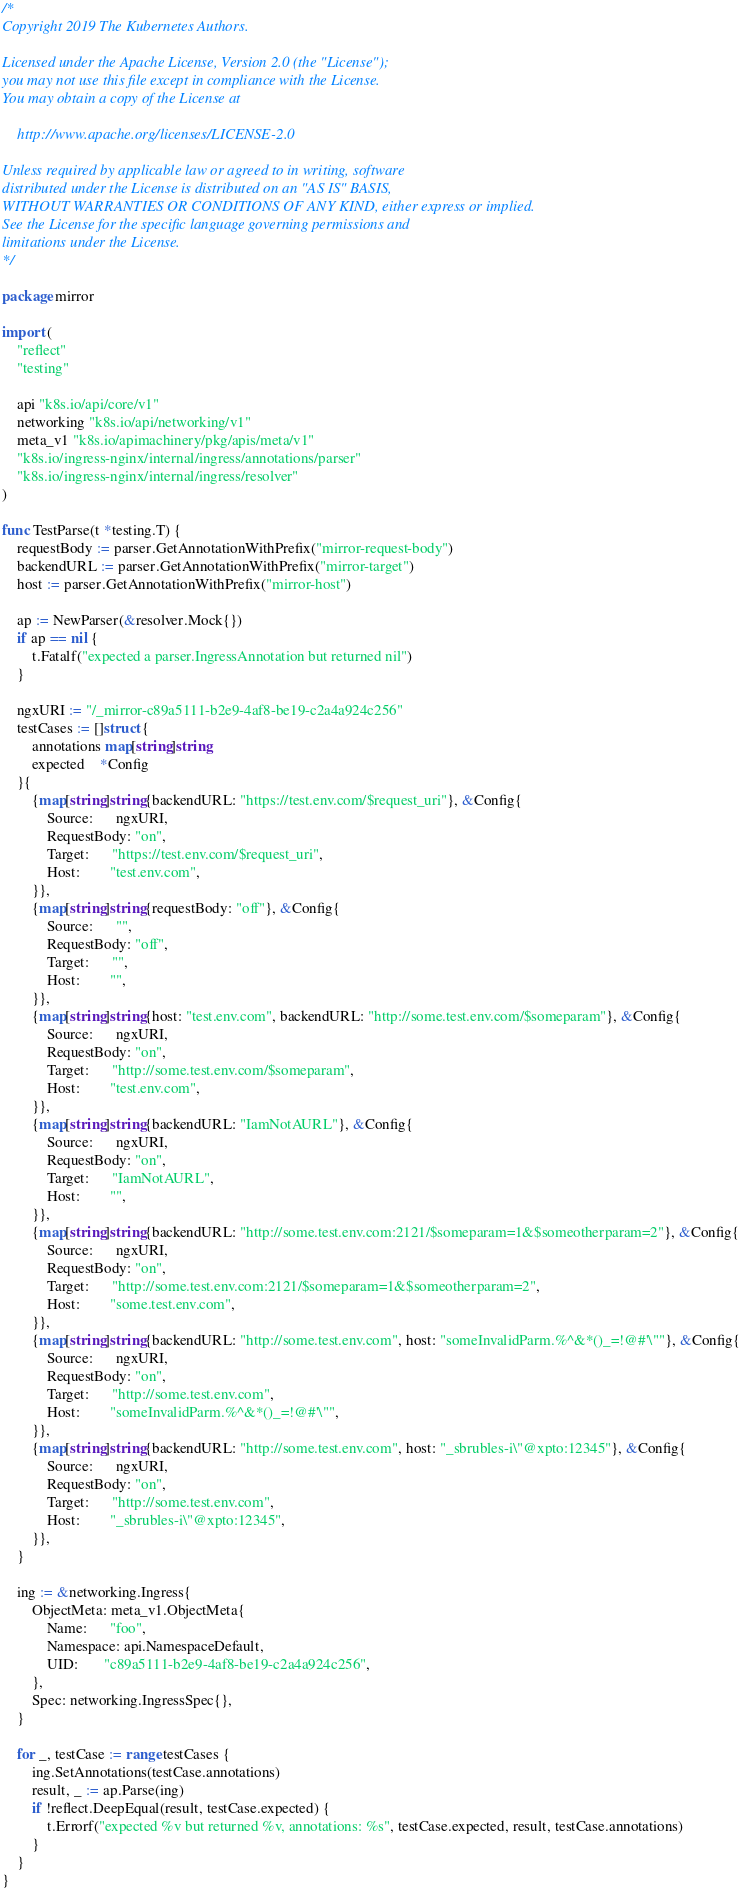<code> <loc_0><loc_0><loc_500><loc_500><_Go_>/*
Copyright 2019 The Kubernetes Authors.

Licensed under the Apache License, Version 2.0 (the "License");
you may not use this file except in compliance with the License.
You may obtain a copy of the License at

    http://www.apache.org/licenses/LICENSE-2.0

Unless required by applicable law or agreed to in writing, software
distributed under the License is distributed on an "AS IS" BASIS,
WITHOUT WARRANTIES OR CONDITIONS OF ANY KIND, either express or implied.
See the License for the specific language governing permissions and
limitations under the License.
*/

package mirror

import (
	"reflect"
	"testing"

	api "k8s.io/api/core/v1"
	networking "k8s.io/api/networking/v1"
	meta_v1 "k8s.io/apimachinery/pkg/apis/meta/v1"
	"k8s.io/ingress-nginx/internal/ingress/annotations/parser"
	"k8s.io/ingress-nginx/internal/ingress/resolver"
)

func TestParse(t *testing.T) {
	requestBody := parser.GetAnnotationWithPrefix("mirror-request-body")
	backendURL := parser.GetAnnotationWithPrefix("mirror-target")
	host := parser.GetAnnotationWithPrefix("mirror-host")

	ap := NewParser(&resolver.Mock{})
	if ap == nil {
		t.Fatalf("expected a parser.IngressAnnotation but returned nil")
	}

	ngxURI := "/_mirror-c89a5111-b2e9-4af8-be19-c2a4a924c256"
	testCases := []struct {
		annotations map[string]string
		expected    *Config
	}{
		{map[string]string{backendURL: "https://test.env.com/$request_uri"}, &Config{
			Source:      ngxURI,
			RequestBody: "on",
			Target:      "https://test.env.com/$request_uri",
			Host:        "test.env.com",
		}},
		{map[string]string{requestBody: "off"}, &Config{
			Source:      "",
			RequestBody: "off",
			Target:      "",
			Host:        "",
		}},
		{map[string]string{host: "test.env.com", backendURL: "http://some.test.env.com/$someparam"}, &Config{
			Source:      ngxURI,
			RequestBody: "on",
			Target:      "http://some.test.env.com/$someparam",
			Host:        "test.env.com",
		}},
		{map[string]string{backendURL: "IamNotAURL"}, &Config{
			Source:      ngxURI,
			RequestBody: "on",
			Target:      "IamNotAURL",
			Host:        "",
		}},
		{map[string]string{backendURL: "http://some.test.env.com:2121/$someparam=1&$someotherparam=2"}, &Config{
			Source:      ngxURI,
			RequestBody: "on",
			Target:      "http://some.test.env.com:2121/$someparam=1&$someotherparam=2",
			Host:        "some.test.env.com",
		}},
		{map[string]string{backendURL: "http://some.test.env.com", host: "someInvalidParm.%^&*()_=!@#'\""}, &Config{
			Source:      ngxURI,
			RequestBody: "on",
			Target:      "http://some.test.env.com",
			Host:        "someInvalidParm.%^&*()_=!@#'\"",
		}},
		{map[string]string{backendURL: "http://some.test.env.com", host: "_sbrubles-i\"@xpto:12345"}, &Config{
			Source:      ngxURI,
			RequestBody: "on",
			Target:      "http://some.test.env.com",
			Host:        "_sbrubles-i\"@xpto:12345",
		}},
	}

	ing := &networking.Ingress{
		ObjectMeta: meta_v1.ObjectMeta{
			Name:      "foo",
			Namespace: api.NamespaceDefault,
			UID:       "c89a5111-b2e9-4af8-be19-c2a4a924c256",
		},
		Spec: networking.IngressSpec{},
	}

	for _, testCase := range testCases {
		ing.SetAnnotations(testCase.annotations)
		result, _ := ap.Parse(ing)
		if !reflect.DeepEqual(result, testCase.expected) {
			t.Errorf("expected %v but returned %v, annotations: %s", testCase.expected, result, testCase.annotations)
		}
	}
}
</code> 